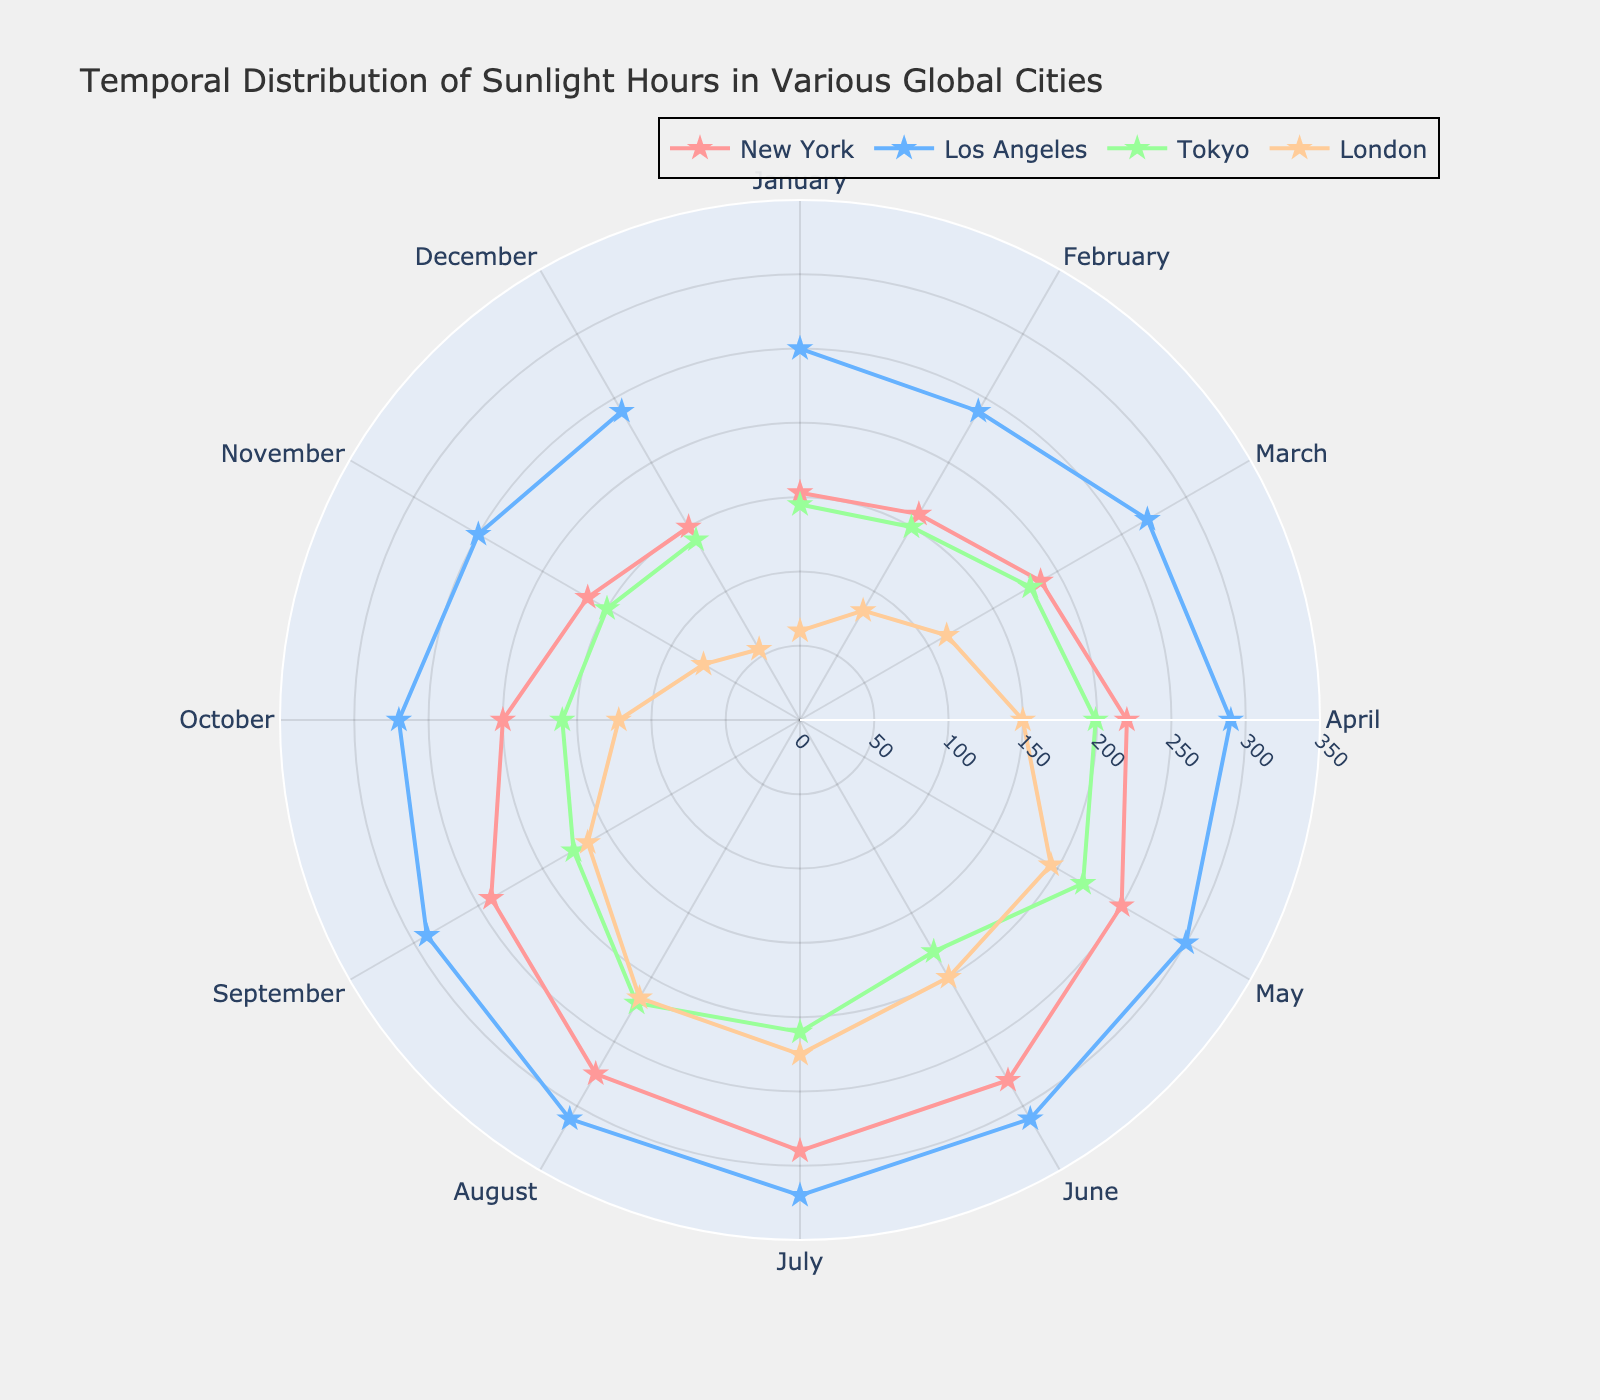What is the title of the chart? The title of the chart is shown at the top of the figure. It reads, "Temporal Distribution of Sunlight Hours in Various Global Cities," which indicates the focus of the chart.
Answer: Temporal Distribution of Sunlight Hours in Various Global Cities Which city has the highest number of sunlight hours in June? To determine which city has the highest sunlight hours in June, look at the data points for each city in June. Los Angeles has the highest sunlight hours with 310 hours.
Answer: Los Angeles What is the range of sunlight hours displayed on the radial axis? The radial axis indicates the range of sunlight hours, marked from 0 to 350 hours. This can be seen by examining the range of the radial axis ticks.
Answer: 0 to 350 What are the sunlight hours in August for London? To find the sunlight hours for London in August, locate the data point for London in August on the chart. The data point shows 216 hours for London in August.
Answer: 216 Which month does New York receive the least amount of sunlight? To find the month with the least sunlight in New York, look for New York's data point with the lowest radial value. The lowest is in December with 150 hours.
Answer: December Compare the sunlight hours in April between New York and Tokyo. To compare, look at the data points for April for both cities. New York has 220 hours, while Tokyo has 199 hours. Therefore, New York has more sunlight hours in April than Tokyo.
Answer: New York has more What is the total number of sunlight hours in March for all the cities combined? Sum the sunlight hours for all cities in March by their respective data points: New York (187) + Los Angeles (270) + Tokyo (179) + London (114). The total is 750 hours.
Answer: 750 Which city experiences the most consistent sunlight hours throughout the year? To determine consistency, observe the fluctuation in sunlight hours for each city throughout the months. Los Angeles has the smallest variation, indicating the most consistent sunlight hours.
Answer: Los Angeles What is the average number of sunlight hours in July for the four cities? To find the average, sum the sunlight hours for July for each city and then divide by four: (New York (290) + Los Angeles (320) + Tokyo (210) + London (225)) / 4. The sum is 1045, so the average is 1045/4 = 261.25 hours.
Answer: 261.25 